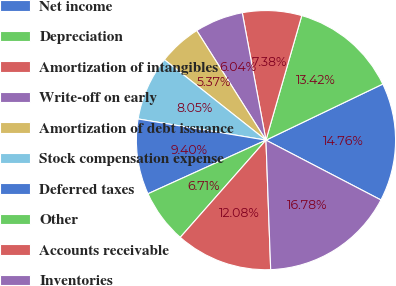Convert chart. <chart><loc_0><loc_0><loc_500><loc_500><pie_chart><fcel>Net income<fcel>Depreciation<fcel>Amortization of intangibles<fcel>Write-off on early<fcel>Amortization of debt issuance<fcel>Stock compensation expense<fcel>Deferred taxes<fcel>Other<fcel>Accounts receivable<fcel>Inventories<nl><fcel>14.76%<fcel>13.42%<fcel>7.38%<fcel>6.04%<fcel>5.37%<fcel>8.05%<fcel>9.4%<fcel>6.71%<fcel>12.08%<fcel>16.78%<nl></chart> 